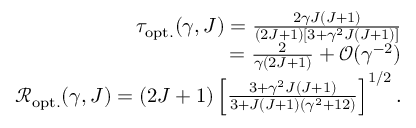Convert formula to latex. <formula><loc_0><loc_0><loc_500><loc_500>\begin{array} { r } { \tau _ { o p t . } ( \gamma , J ) = \frac { 2 \gamma J ( J + 1 ) } { ( 2 J + 1 ) \left [ 3 + \gamma ^ { 2 } J ( J + 1 ) \right ] } } \\ { = \frac { 2 } { \gamma ( 2 J + 1 ) } + \mathcal { O } ( \gamma ^ { - 2 } ) } \\ { \mathcal { R } _ { o p t . } ( \gamma , J ) = ( 2 J + 1 ) \left [ \frac { 3 + \gamma ^ { 2 } J ( J + 1 ) } { 3 + J ( J + 1 ) ( \gamma ^ { 2 } + 1 2 ) } \right ] ^ { 1 / 2 } . } \end{array}</formula> 